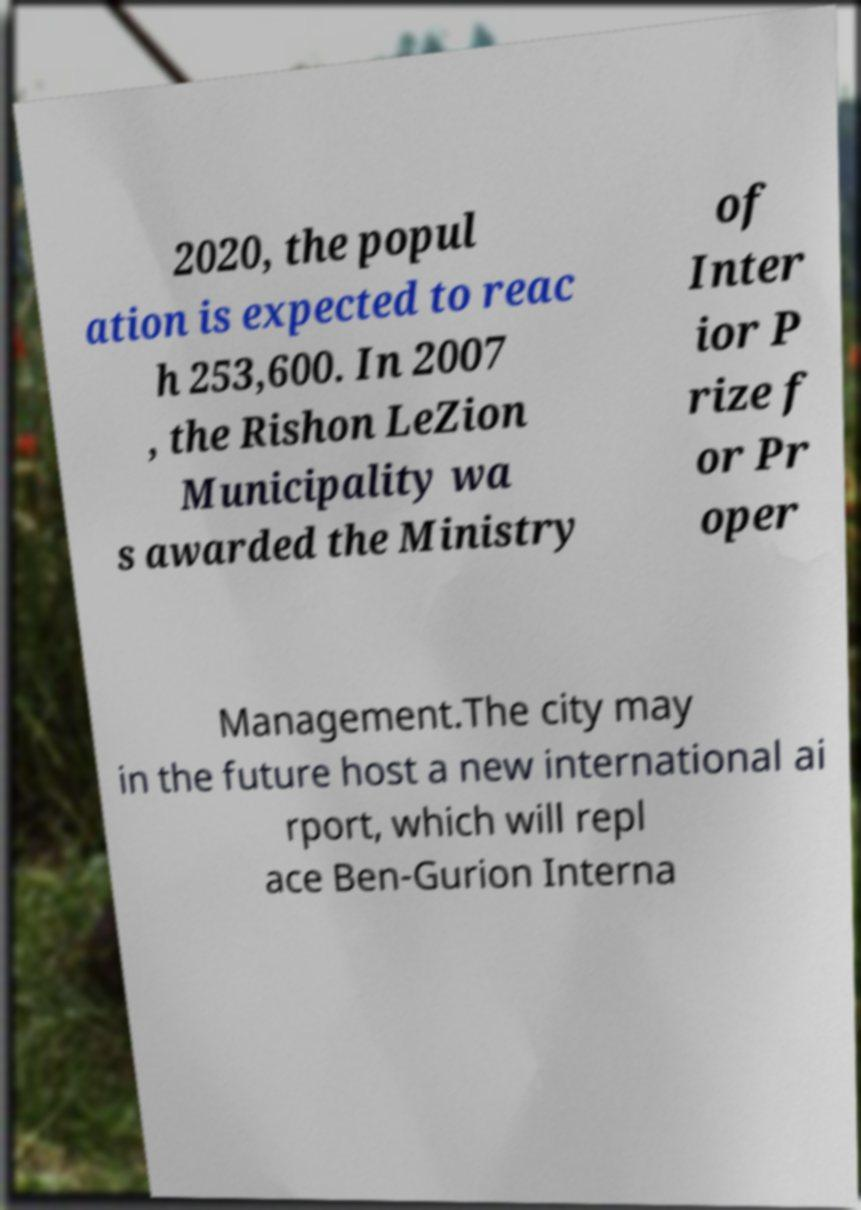There's text embedded in this image that I need extracted. Can you transcribe it verbatim? 2020, the popul ation is expected to reac h 253,600. In 2007 , the Rishon LeZion Municipality wa s awarded the Ministry of Inter ior P rize f or Pr oper Management.The city may in the future host a new international ai rport, which will repl ace Ben-Gurion Interna 